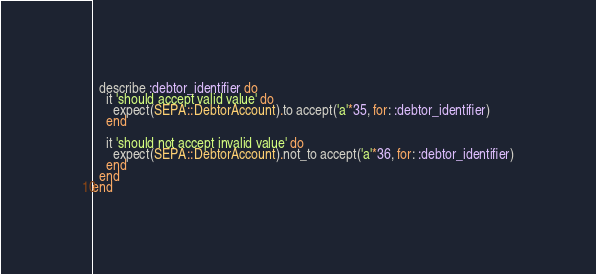<code> <loc_0><loc_0><loc_500><loc_500><_Ruby_>
  describe :debtor_identifier do
    it 'should accept valid value' do
      expect(SEPA::DebtorAccount).to accept('a'*35, for: :debtor_identifier)
    end

    it 'should not accept invalid value' do
      expect(SEPA::DebtorAccount).not_to accept('a'*36, for: :debtor_identifier)
    end
  end
end
</code> 